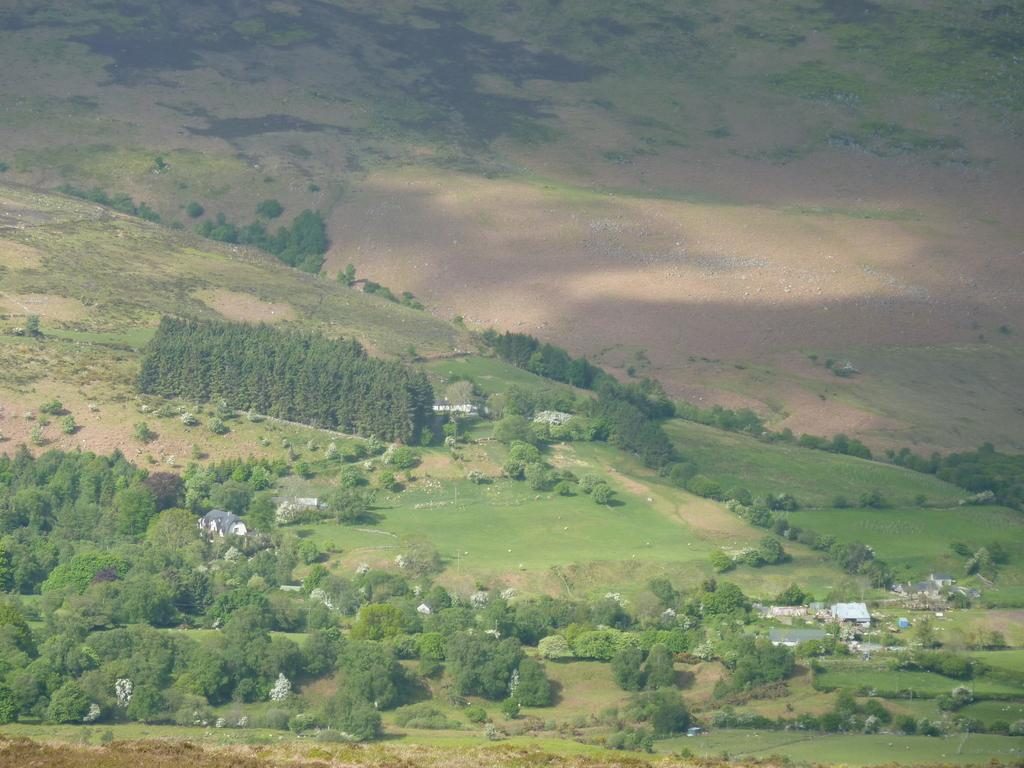What type of view is provided in the image? The image is an aerial view. What type of landscape can be seen in the image? There are grasslands visible in the image. What type of vegetation is present in the image? Trees are present in the image. What type of structures can be seen in the image? Houses are visible in the image. What type of desk can be seen in the image? There is no desk present in the image. Can you describe the nose of the person in the image? There is no person present in the image, so it is not possible to describe a nose. 